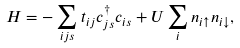<formula> <loc_0><loc_0><loc_500><loc_500>H = - \sum _ { i j s } t _ { i j } c _ { j s } ^ { \dagger } c _ { i s } + U \sum _ { i } n _ { i \uparrow } n _ { i \downarrow } ,</formula> 